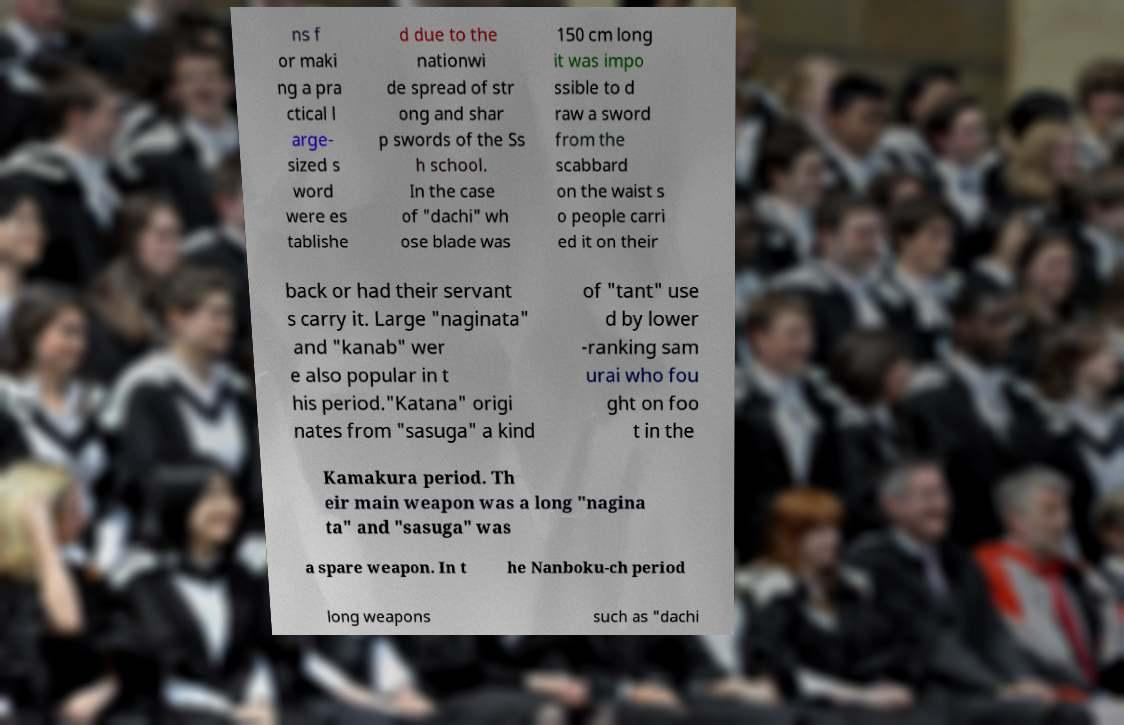Could you assist in decoding the text presented in this image and type it out clearly? ns f or maki ng a pra ctical l arge- sized s word were es tablishe d due to the nationwi de spread of str ong and shar p swords of the Ss h school. In the case of "dachi" wh ose blade was 150 cm long it was impo ssible to d raw a sword from the scabbard on the waist s o people carri ed it on their back or had their servant s carry it. Large "naginata" and "kanab" wer e also popular in t his period."Katana" origi nates from "sasuga" a kind of "tant" use d by lower -ranking sam urai who fou ght on foo t in the Kamakura period. Th eir main weapon was a long "nagina ta" and "sasuga" was a spare weapon. In t he Nanboku-ch period long weapons such as "dachi 